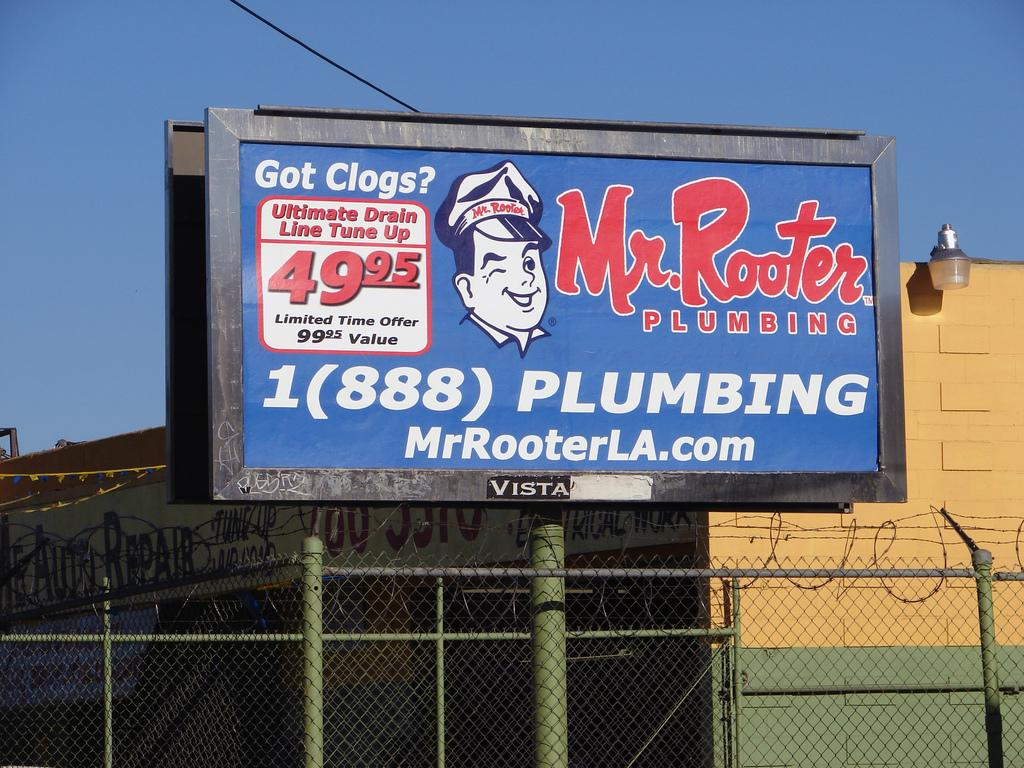<image>
Render a clear and concise summary of the photo. A banner with Mr. Rooter plumbing information wrote on it 